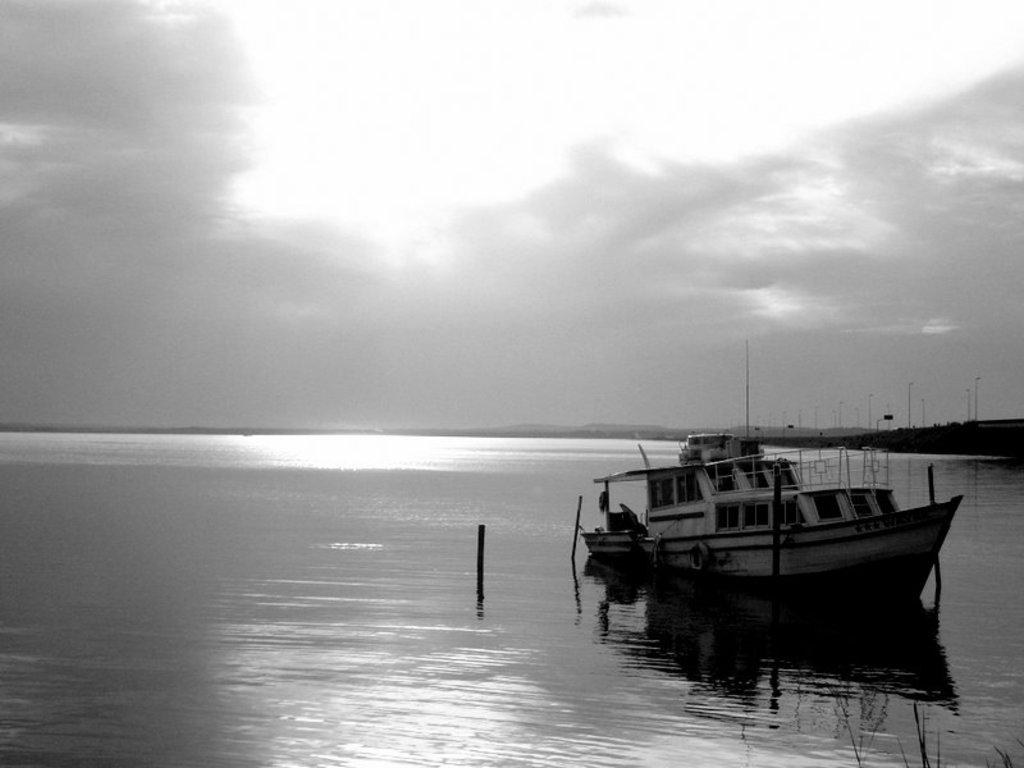What is the color scheme of the image? The image is black and white. What can be seen in the water in the image? There is a boat in the water. What structures are present with lights in the image? There are poles with lights in the image. What is visible in the background of the image? The sky with clouds is visible in the background. How many parts of a bee can be seen in the image? There are no bees present in the image, so it is not possible to see any parts of a bee. What type of quarter is depicted in the image? There is no reference to a quarter or any currency in the image. 